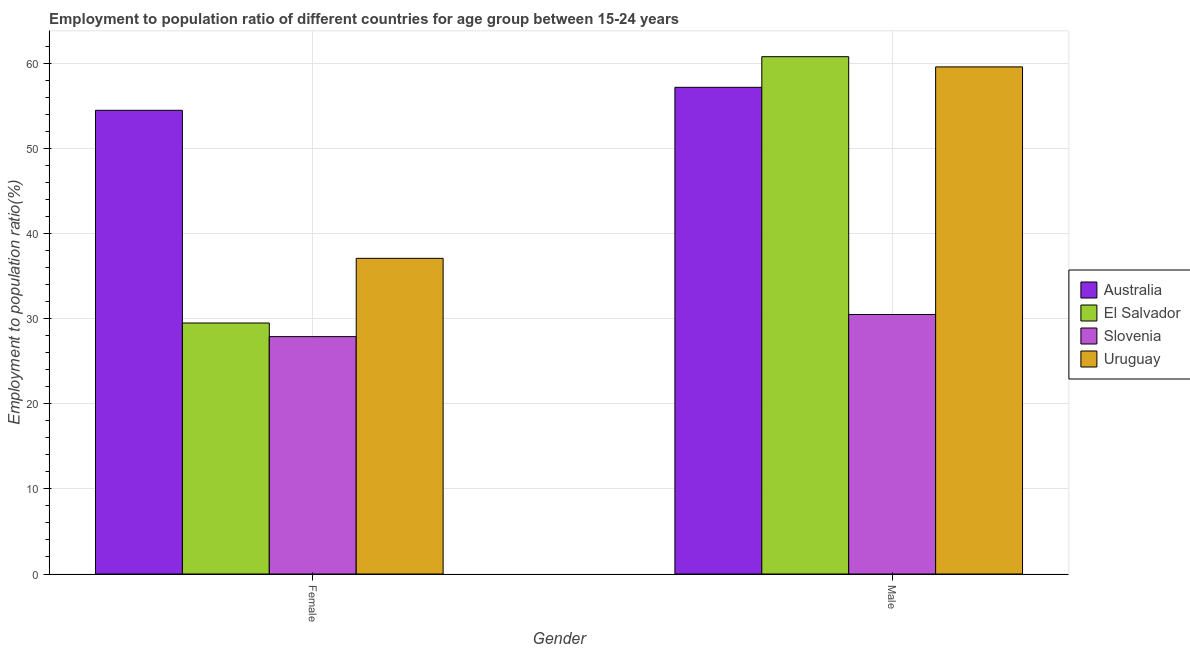How many groups of bars are there?
Keep it short and to the point. 2. How many bars are there on the 1st tick from the left?
Make the answer very short. 4. What is the label of the 2nd group of bars from the left?
Your response must be concise. Male. What is the employment to population ratio(male) in Australia?
Offer a very short reply. 57.2. Across all countries, what is the maximum employment to population ratio(male)?
Ensure brevity in your answer.  60.8. Across all countries, what is the minimum employment to population ratio(male)?
Keep it short and to the point. 30.5. In which country was the employment to population ratio(male) maximum?
Your response must be concise. El Salvador. In which country was the employment to population ratio(female) minimum?
Provide a short and direct response. Slovenia. What is the total employment to population ratio(male) in the graph?
Offer a very short reply. 208.1. What is the difference between the employment to population ratio(female) in El Salvador and that in Slovenia?
Make the answer very short. 1.6. What is the difference between the employment to population ratio(female) in Slovenia and the employment to population ratio(male) in El Salvador?
Provide a succinct answer. -32.9. What is the average employment to population ratio(male) per country?
Provide a short and direct response. 52.02. What is the difference between the employment to population ratio(female) and employment to population ratio(male) in El Salvador?
Ensure brevity in your answer.  -31.3. What is the ratio of the employment to population ratio(female) in El Salvador to that in Australia?
Offer a very short reply. 0.54. Is the employment to population ratio(female) in Uruguay less than that in Slovenia?
Give a very brief answer. No. What does the 3rd bar from the right in Male represents?
Keep it short and to the point. El Salvador. How many bars are there?
Your answer should be compact. 8. Are all the bars in the graph horizontal?
Your response must be concise. No. Are the values on the major ticks of Y-axis written in scientific E-notation?
Your answer should be compact. No. Does the graph contain any zero values?
Ensure brevity in your answer.  No. Does the graph contain grids?
Your answer should be compact. Yes. How are the legend labels stacked?
Keep it short and to the point. Vertical. What is the title of the graph?
Offer a very short reply. Employment to population ratio of different countries for age group between 15-24 years. Does "Korea (Republic)" appear as one of the legend labels in the graph?
Keep it short and to the point. No. What is the Employment to population ratio(%) in Australia in Female?
Your answer should be very brief. 54.5. What is the Employment to population ratio(%) in El Salvador in Female?
Your response must be concise. 29.5. What is the Employment to population ratio(%) of Slovenia in Female?
Your response must be concise. 27.9. What is the Employment to population ratio(%) in Uruguay in Female?
Provide a short and direct response. 37.1. What is the Employment to population ratio(%) of Australia in Male?
Your answer should be compact. 57.2. What is the Employment to population ratio(%) in El Salvador in Male?
Make the answer very short. 60.8. What is the Employment to population ratio(%) in Slovenia in Male?
Offer a terse response. 30.5. What is the Employment to population ratio(%) of Uruguay in Male?
Offer a very short reply. 59.6. Across all Gender, what is the maximum Employment to population ratio(%) in Australia?
Your answer should be compact. 57.2. Across all Gender, what is the maximum Employment to population ratio(%) in El Salvador?
Give a very brief answer. 60.8. Across all Gender, what is the maximum Employment to population ratio(%) in Slovenia?
Offer a terse response. 30.5. Across all Gender, what is the maximum Employment to population ratio(%) in Uruguay?
Ensure brevity in your answer.  59.6. Across all Gender, what is the minimum Employment to population ratio(%) in Australia?
Make the answer very short. 54.5. Across all Gender, what is the minimum Employment to population ratio(%) in El Salvador?
Ensure brevity in your answer.  29.5. Across all Gender, what is the minimum Employment to population ratio(%) of Slovenia?
Offer a very short reply. 27.9. Across all Gender, what is the minimum Employment to population ratio(%) in Uruguay?
Provide a short and direct response. 37.1. What is the total Employment to population ratio(%) of Australia in the graph?
Your response must be concise. 111.7. What is the total Employment to population ratio(%) in El Salvador in the graph?
Give a very brief answer. 90.3. What is the total Employment to population ratio(%) in Slovenia in the graph?
Make the answer very short. 58.4. What is the total Employment to population ratio(%) in Uruguay in the graph?
Offer a terse response. 96.7. What is the difference between the Employment to population ratio(%) of Australia in Female and that in Male?
Give a very brief answer. -2.7. What is the difference between the Employment to population ratio(%) of El Salvador in Female and that in Male?
Keep it short and to the point. -31.3. What is the difference between the Employment to population ratio(%) of Slovenia in Female and that in Male?
Your answer should be compact. -2.6. What is the difference between the Employment to population ratio(%) of Uruguay in Female and that in Male?
Give a very brief answer. -22.5. What is the difference between the Employment to population ratio(%) in El Salvador in Female and the Employment to population ratio(%) in Uruguay in Male?
Give a very brief answer. -30.1. What is the difference between the Employment to population ratio(%) in Slovenia in Female and the Employment to population ratio(%) in Uruguay in Male?
Your answer should be compact. -31.7. What is the average Employment to population ratio(%) of Australia per Gender?
Provide a succinct answer. 55.85. What is the average Employment to population ratio(%) of El Salvador per Gender?
Your answer should be very brief. 45.15. What is the average Employment to population ratio(%) in Slovenia per Gender?
Your response must be concise. 29.2. What is the average Employment to population ratio(%) in Uruguay per Gender?
Your answer should be very brief. 48.35. What is the difference between the Employment to population ratio(%) in Australia and Employment to population ratio(%) in El Salvador in Female?
Keep it short and to the point. 25. What is the difference between the Employment to population ratio(%) of Australia and Employment to population ratio(%) of Slovenia in Female?
Your response must be concise. 26.6. What is the difference between the Employment to population ratio(%) of Australia and Employment to population ratio(%) of Uruguay in Female?
Offer a very short reply. 17.4. What is the difference between the Employment to population ratio(%) of El Salvador and Employment to population ratio(%) of Slovenia in Female?
Offer a terse response. 1.6. What is the difference between the Employment to population ratio(%) in Australia and Employment to population ratio(%) in El Salvador in Male?
Provide a succinct answer. -3.6. What is the difference between the Employment to population ratio(%) of Australia and Employment to population ratio(%) of Slovenia in Male?
Your answer should be compact. 26.7. What is the difference between the Employment to population ratio(%) in El Salvador and Employment to population ratio(%) in Slovenia in Male?
Offer a very short reply. 30.3. What is the difference between the Employment to population ratio(%) in El Salvador and Employment to population ratio(%) in Uruguay in Male?
Your answer should be compact. 1.2. What is the difference between the Employment to population ratio(%) of Slovenia and Employment to population ratio(%) of Uruguay in Male?
Provide a succinct answer. -29.1. What is the ratio of the Employment to population ratio(%) in Australia in Female to that in Male?
Your answer should be compact. 0.95. What is the ratio of the Employment to population ratio(%) in El Salvador in Female to that in Male?
Make the answer very short. 0.49. What is the ratio of the Employment to population ratio(%) in Slovenia in Female to that in Male?
Make the answer very short. 0.91. What is the ratio of the Employment to population ratio(%) in Uruguay in Female to that in Male?
Offer a terse response. 0.62. What is the difference between the highest and the second highest Employment to population ratio(%) of El Salvador?
Offer a terse response. 31.3. What is the difference between the highest and the lowest Employment to population ratio(%) of El Salvador?
Give a very brief answer. 31.3. 